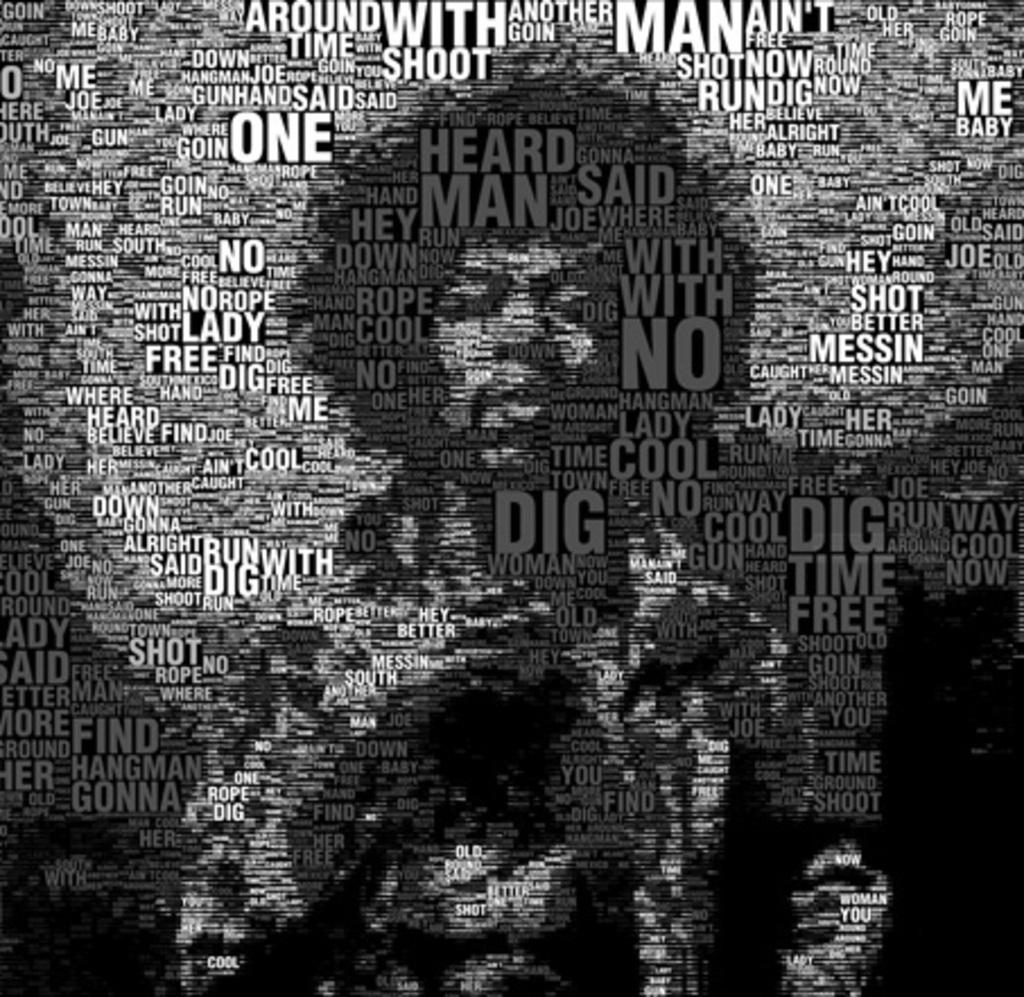Provide a one-sentence caption for the provided image. A word cloud type of graphic contains the word "dig" multiple times. 